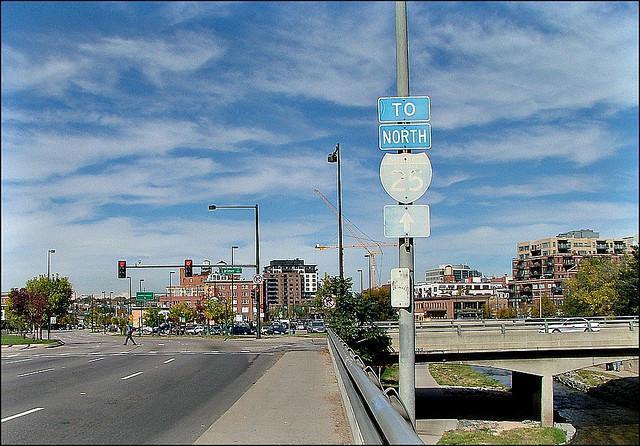How many sinks are there?
Give a very brief answer. 0. 